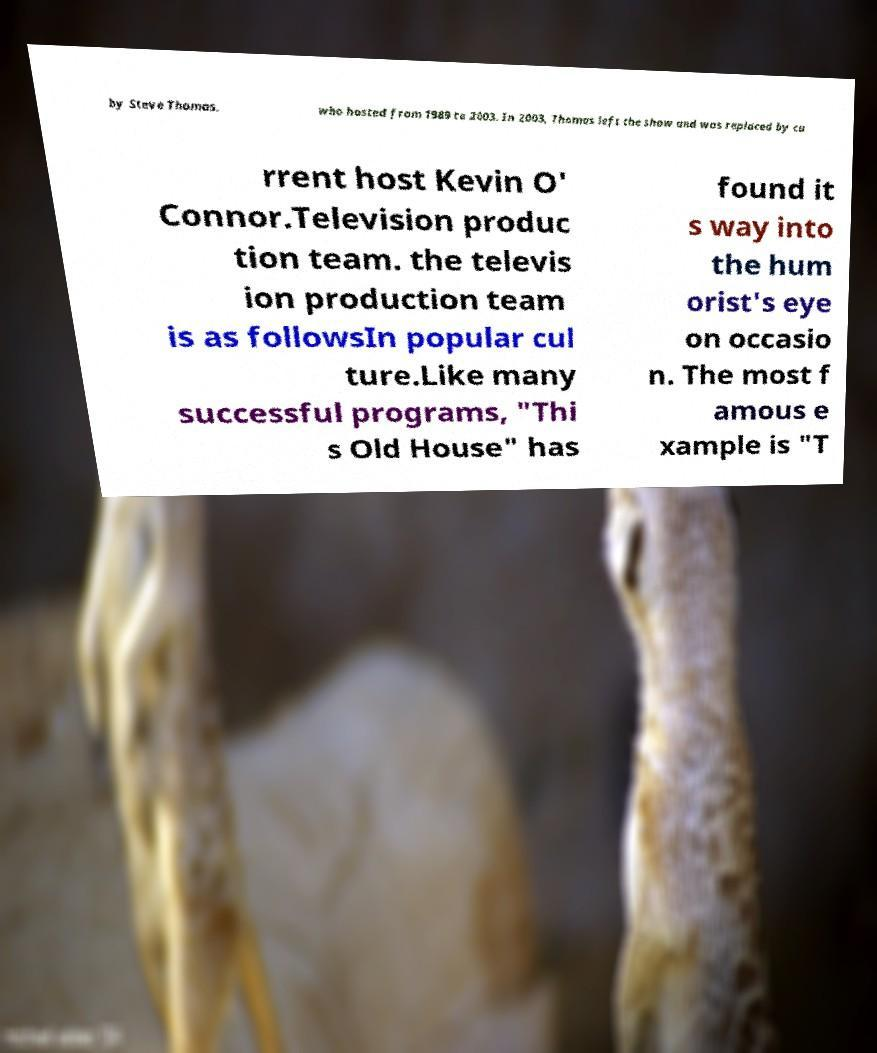Could you extract and type out the text from this image? by Steve Thomas, who hosted from 1989 to 2003. In 2003, Thomas left the show and was replaced by cu rrent host Kevin O' Connor.Television produc tion team. the televis ion production team is as followsIn popular cul ture.Like many successful programs, "Thi s Old House" has found it s way into the hum orist's eye on occasio n. The most f amous e xample is "T 